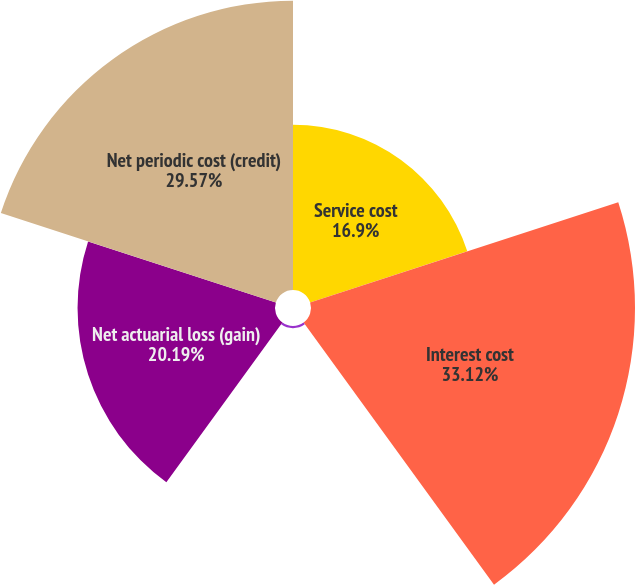<chart> <loc_0><loc_0><loc_500><loc_500><pie_chart><fcel>Service cost<fcel>Interest cost<fcel>Prior service credit<fcel>Net actuarial loss (gain)<fcel>Net periodic cost (credit)<nl><fcel>16.9%<fcel>33.13%<fcel>0.22%<fcel>20.19%<fcel>29.57%<nl></chart> 